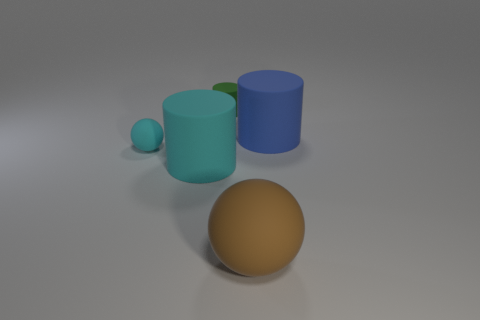Subtract all big cylinders. How many cylinders are left? 1 Add 3 tiny yellow shiny balls. How many objects exist? 8 Subtract all spheres. How many objects are left? 3 Subtract 0 brown cubes. How many objects are left? 5 Subtract all large cyan cylinders. Subtract all large cyan metallic spheres. How many objects are left? 4 Add 1 big balls. How many big balls are left? 2 Add 3 purple metallic cubes. How many purple metallic cubes exist? 3 